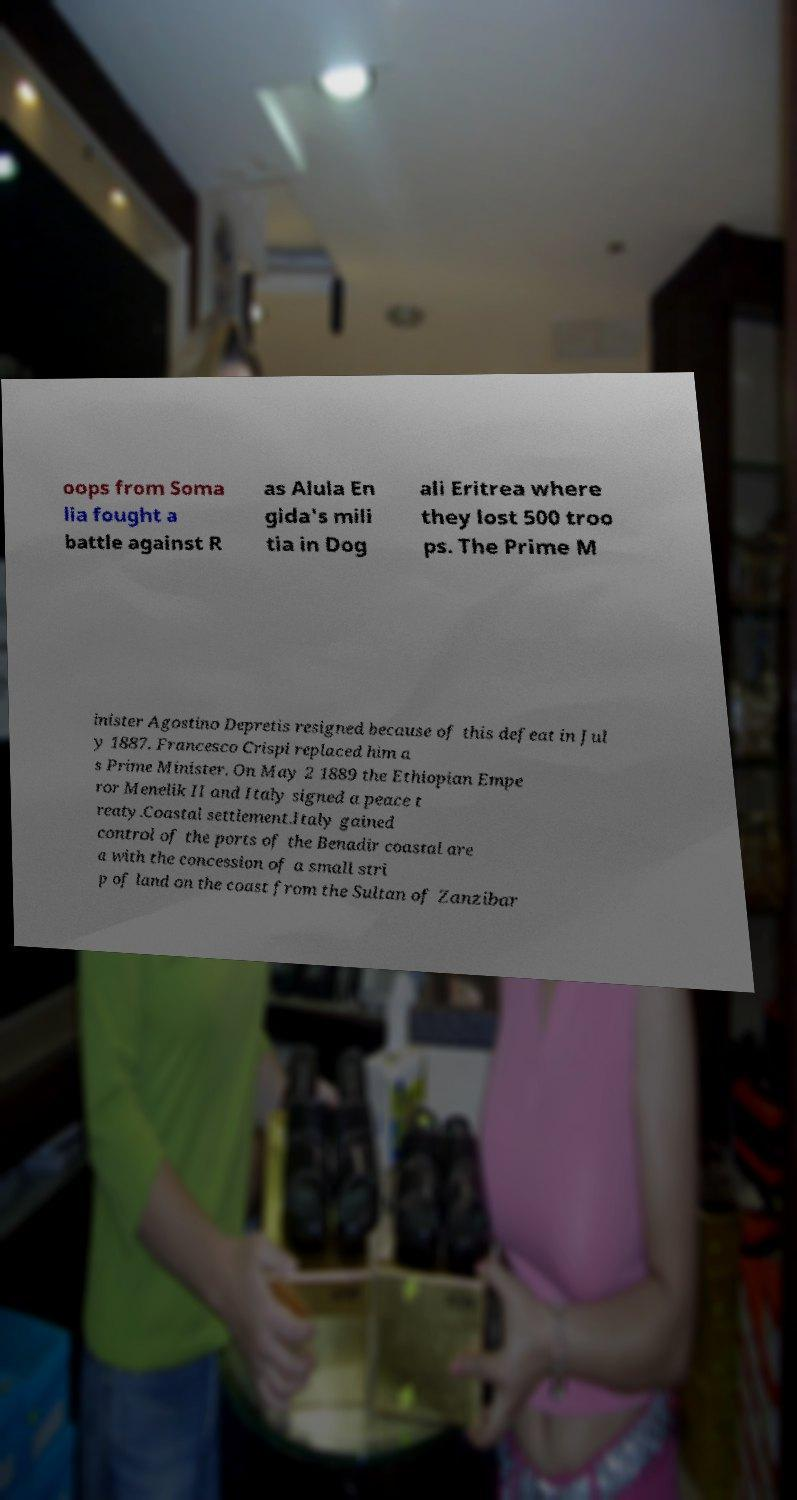There's text embedded in this image that I need extracted. Can you transcribe it verbatim? oops from Soma lia fought a battle against R as Alula En gida's mili tia in Dog ali Eritrea where they lost 500 troo ps. The Prime M inister Agostino Depretis resigned because of this defeat in Jul y 1887. Francesco Crispi replaced him a s Prime Minister. On May 2 1889 the Ethiopian Empe ror Menelik II and Italy signed a peace t reaty.Coastal settlement.Italy gained control of the ports of the Benadir coastal are a with the concession of a small stri p of land on the coast from the Sultan of Zanzibar 